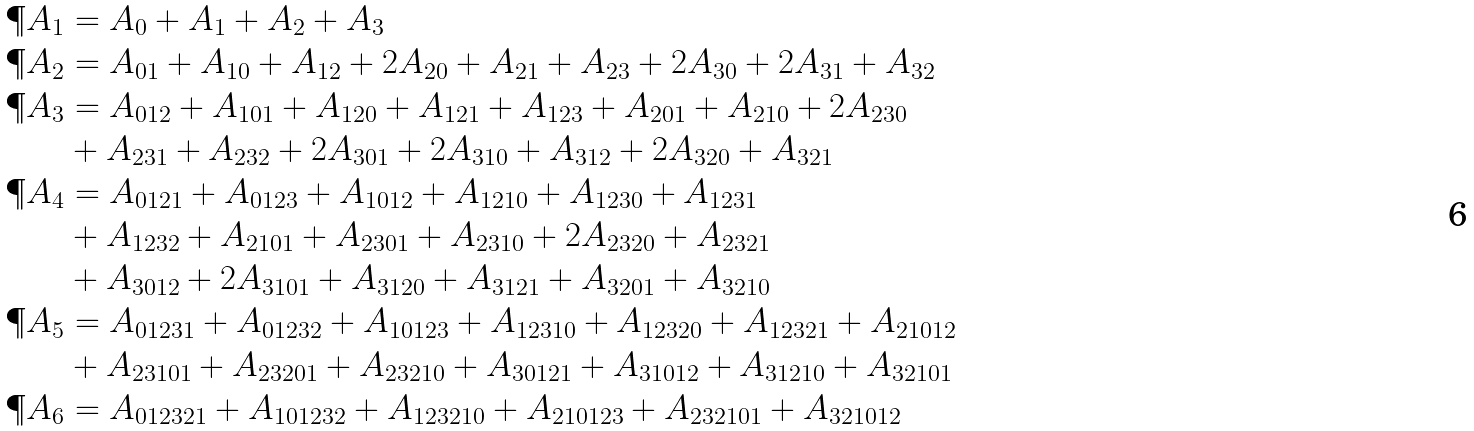<formula> <loc_0><loc_0><loc_500><loc_500>\P A _ { 1 } & = A _ { 0 } + A _ { 1 } + A _ { 2 } + A _ { 3 } \\ \P A _ { 2 } & = A _ { 0 1 } + A _ { 1 0 } + A _ { 1 2 } + 2 A _ { 2 0 } + A _ { 2 1 } + A _ { 2 3 } + 2 A _ { 3 0 } + 2 A _ { 3 1 } + A _ { 3 2 } \\ \P A _ { 3 } & = A _ { 0 1 2 } + A _ { 1 0 1 } + A _ { 1 2 0 } + A _ { 1 2 1 } + A _ { 1 2 3 } + A _ { 2 0 1 } + A _ { 2 1 0 } + 2 A _ { 2 3 0 } \\ & + A _ { 2 3 1 } + A _ { 2 3 2 } + 2 A _ { 3 0 1 } + 2 A _ { 3 1 0 } + A _ { 3 1 2 } + 2 A _ { 3 2 0 } + A _ { 3 2 1 } \\ \P A _ { 4 } & = A _ { 0 1 2 1 } + A _ { 0 1 2 3 } + A _ { 1 0 1 2 } + A _ { 1 2 1 0 } + A _ { 1 2 3 0 } + A _ { 1 2 3 1 } \\ & + A _ { 1 2 3 2 } + A _ { 2 1 0 1 } + A _ { 2 3 0 1 } + A _ { 2 3 1 0 } + 2 A _ { 2 3 2 0 } + A _ { 2 3 2 1 } \\ & + A _ { 3 0 1 2 } + 2 A _ { 3 1 0 1 } + A _ { 3 1 2 0 } + A _ { 3 1 2 1 } + A _ { 3 2 0 1 } + A _ { 3 2 1 0 } \\ \P A _ { 5 } & = A _ { 0 1 2 3 1 } + A _ { 0 1 2 3 2 } + A _ { 1 0 1 2 3 } + A _ { 1 2 3 1 0 } + A _ { 1 2 3 2 0 } + A _ { 1 2 3 2 1 } + A _ { 2 1 0 1 2 } \\ & + A _ { 2 3 1 0 1 } + A _ { 2 3 2 0 1 } + A _ { 2 3 2 1 0 } + A _ { 3 0 1 2 1 } + A _ { 3 1 0 1 2 } + A _ { 3 1 2 1 0 } + A _ { 3 2 1 0 1 } \\ \P A _ { 6 } & = A _ { 0 1 2 3 2 1 } + A _ { 1 0 1 2 3 2 } + A _ { 1 2 3 2 1 0 } + A _ { 2 1 0 1 2 3 } + A _ { 2 3 2 1 0 1 } + A _ { 3 2 1 0 1 2 }</formula> 